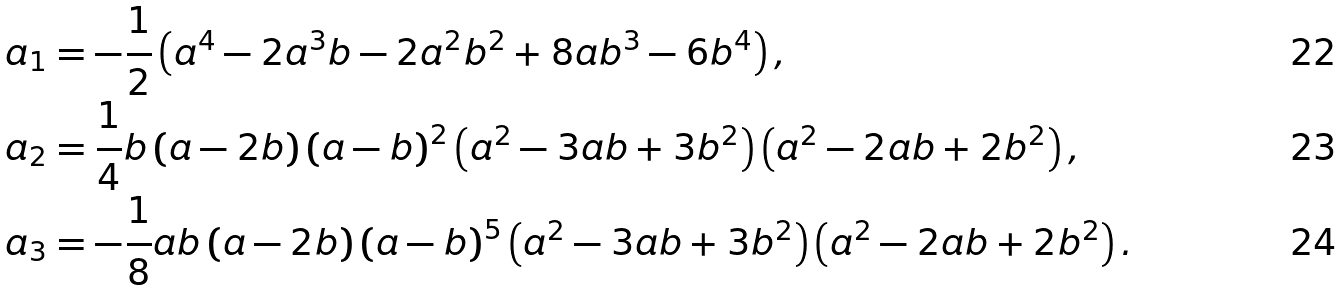Convert formula to latex. <formula><loc_0><loc_0><loc_500><loc_500>a _ { 1 } & = - \frac { 1 } { 2 } \left ( a ^ { 4 } - 2 a ^ { 3 } b - 2 a ^ { 2 } b ^ { 2 } + 8 a b ^ { 3 } - 6 b ^ { 4 } \right ) , \\ a _ { 2 } & = \frac { 1 } { 4 } b \left ( a - 2 b \right ) \left ( a - b \right ) ^ { 2 } \left ( a ^ { 2 } - 3 a b + 3 b ^ { 2 } \right ) \left ( a ^ { 2 } - 2 a b + 2 b ^ { 2 } \right ) , \\ a _ { 3 } & = - \frac { 1 } { 8 } a b \left ( a - 2 b \right ) \left ( a - b \right ) ^ { 5 } \left ( a ^ { 2 } - 3 a b + 3 b ^ { 2 } \right ) \left ( a ^ { 2 } - 2 a b + 2 b ^ { 2 } \right ) .</formula> 